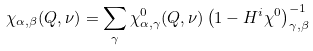Convert formula to latex. <formula><loc_0><loc_0><loc_500><loc_500>\chi _ { \alpha , \beta } ( Q , \nu ) = \sum _ { \gamma } \chi ^ { 0 } _ { \alpha , \gamma } ( Q , \nu ) \left ( 1 - H ^ { i } \chi ^ { 0 } \right ) ^ { - 1 } _ { \gamma , \beta }</formula> 